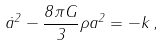Convert formula to latex. <formula><loc_0><loc_0><loc_500><loc_500>\dot { a } ^ { 2 } - \frac { 8 \pi G } { 3 } \rho a ^ { 2 } = - k \, ,</formula> 